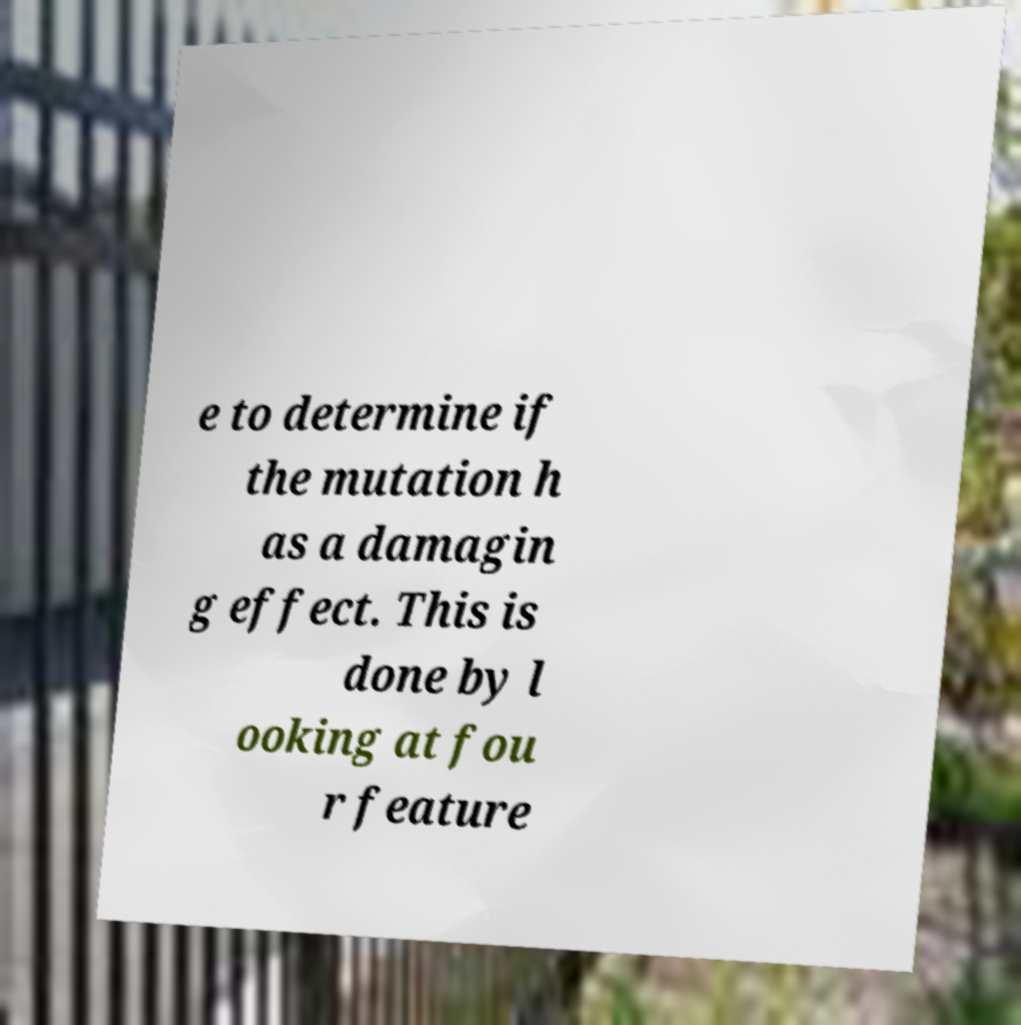There's text embedded in this image that I need extracted. Can you transcribe it verbatim? e to determine if the mutation h as a damagin g effect. This is done by l ooking at fou r feature 